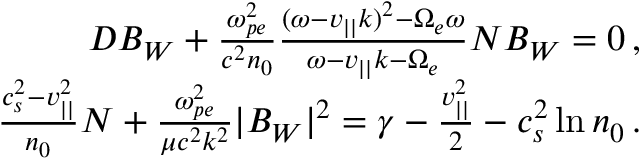Convert formula to latex. <formula><loc_0><loc_0><loc_500><loc_500>\begin{array} { r } { D B _ { W } + \frac { \omega _ { p e } ^ { 2 } } { c ^ { 2 } n _ { 0 } } \frac { ( \omega - v _ { | | } k ) ^ { 2 } - \Omega _ { e } \omega } { \omega - v _ { | | } k - \Omega _ { e } } N B _ { W } = 0 \, , } \\ { \frac { c _ { s } ^ { 2 } - v _ { | | } ^ { 2 } } { n _ { 0 } } N + \frac { \omega _ { p e } ^ { 2 } } { \mu c ^ { 2 } k ^ { 2 } } | B _ { W } | ^ { 2 } = \gamma - \frac { v _ { | | } ^ { 2 } } { 2 } - c _ { s } ^ { 2 } \ln n _ { 0 } \, . } \end{array}</formula> 